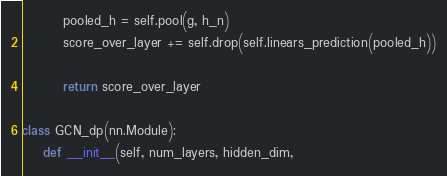Convert code to text. <code><loc_0><loc_0><loc_500><loc_500><_Python_>        pooled_h = self.pool(g, h_n)
        score_over_layer += self.drop(self.linears_prediction(pooled_h))

        return score_over_layer

class GCN_dp(nn.Module):
    def __init__(self, num_layers, hidden_dim,</code> 